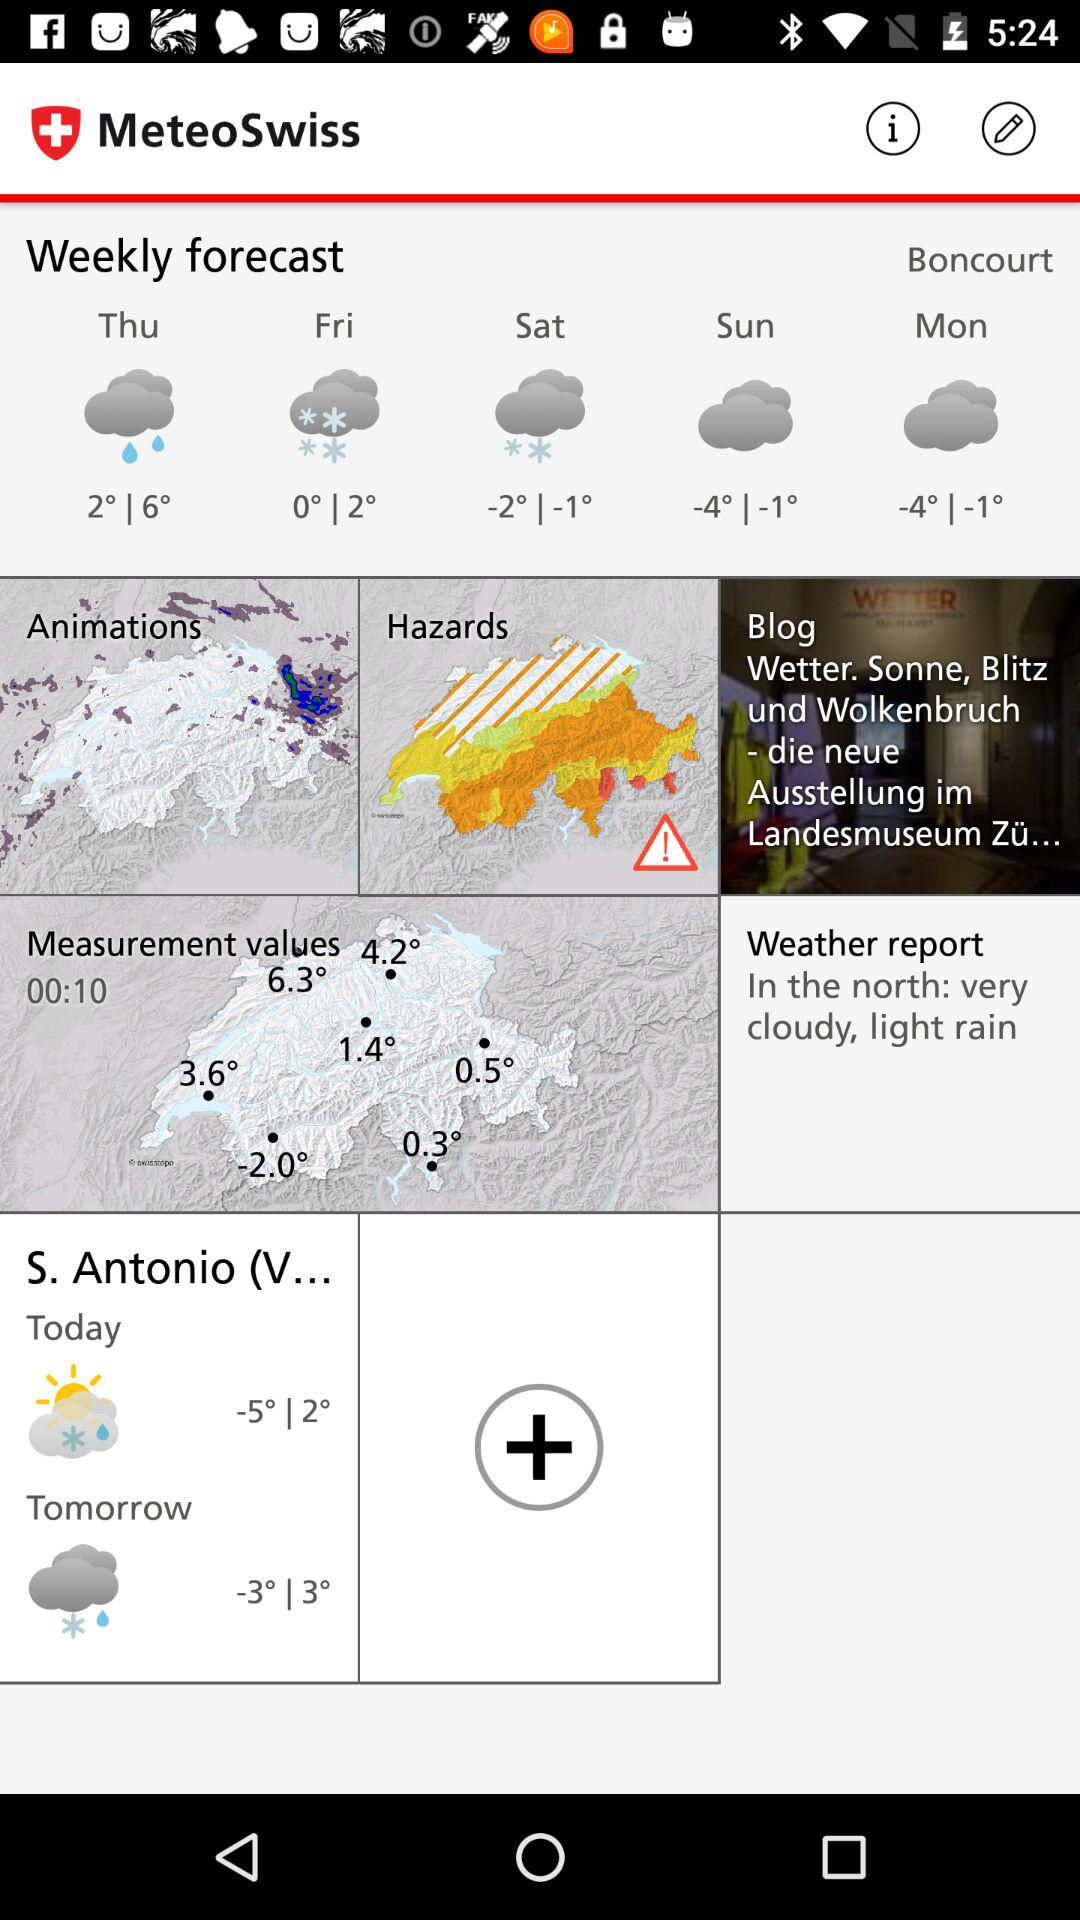What is the temperature tomorrow? The temperature tomorrow will range from -3 degrees to 3 degrees. 